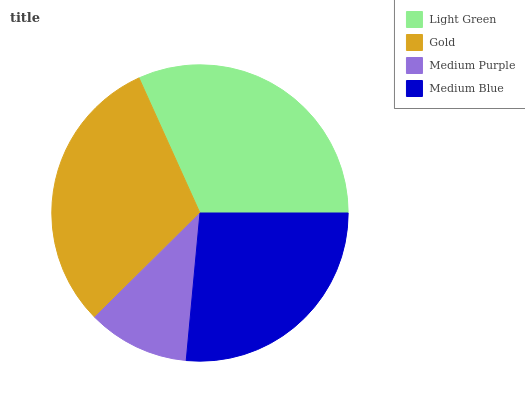Is Medium Purple the minimum?
Answer yes or no. Yes. Is Light Green the maximum?
Answer yes or no. Yes. Is Gold the minimum?
Answer yes or no. No. Is Gold the maximum?
Answer yes or no. No. Is Light Green greater than Gold?
Answer yes or no. Yes. Is Gold less than Light Green?
Answer yes or no. Yes. Is Gold greater than Light Green?
Answer yes or no. No. Is Light Green less than Gold?
Answer yes or no. No. Is Gold the high median?
Answer yes or no. Yes. Is Medium Blue the low median?
Answer yes or no. Yes. Is Medium Purple the high median?
Answer yes or no. No. Is Medium Purple the low median?
Answer yes or no. No. 